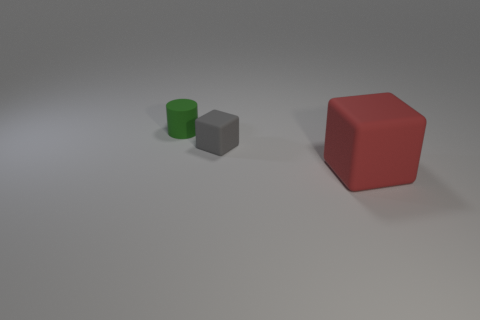There is a matte object that is both right of the green cylinder and behind the big red matte cube; what shape is it? cube 